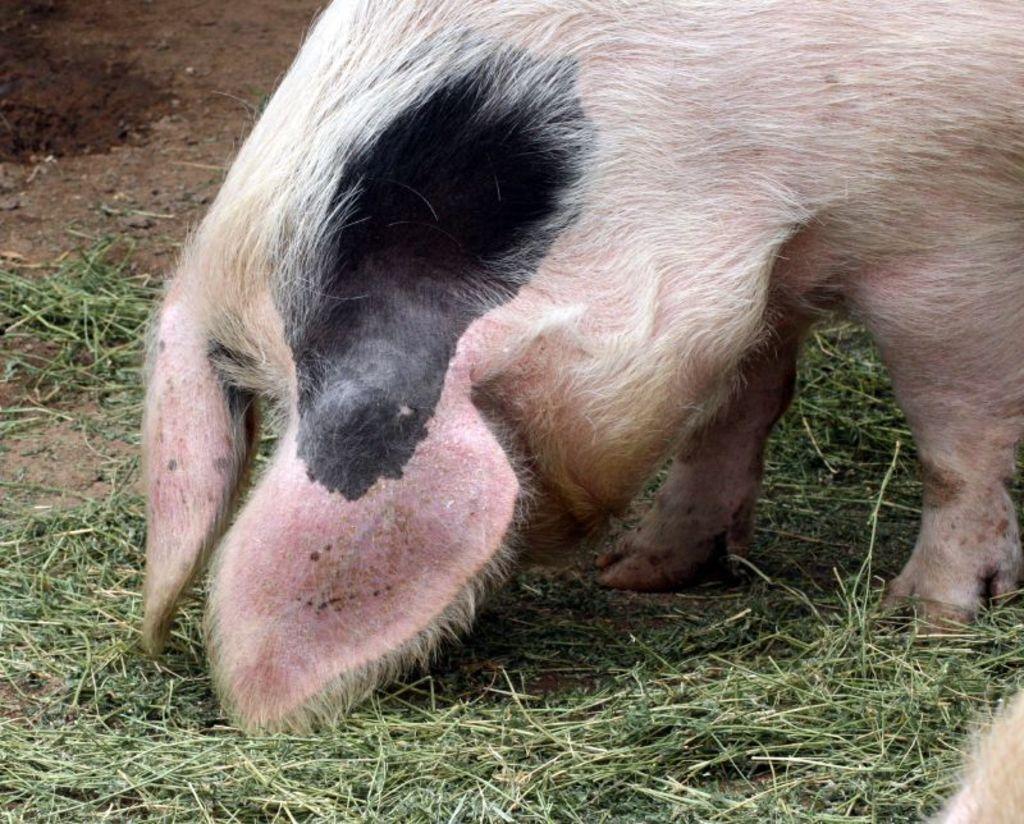Please provide a concise description of this image. In the center of the image we can see pig on the grass. 